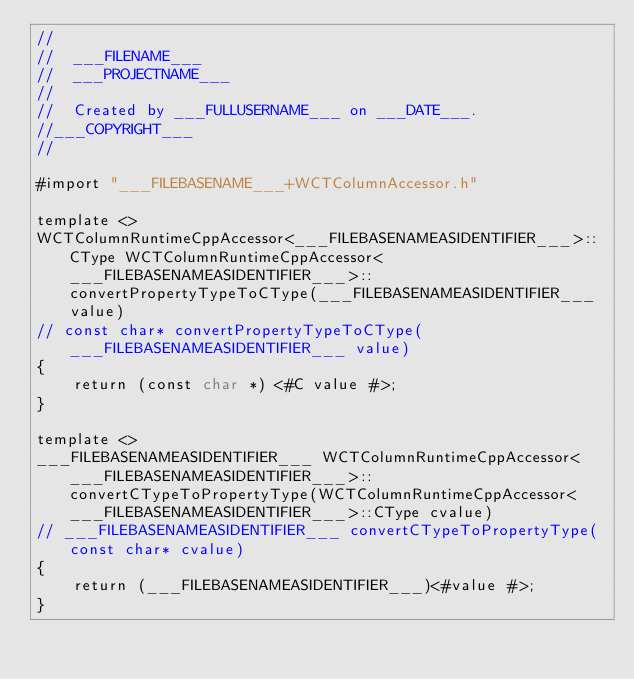<code> <loc_0><loc_0><loc_500><loc_500><_ObjectiveC_>//
//  ___FILENAME___
//  ___PROJECTNAME___
//
//  Created by ___FULLUSERNAME___ on ___DATE___.
//___COPYRIGHT___
//

#import "___FILEBASENAME___+WCTColumnAccessor.h"

template <>
WCTColumnRuntimeCppAccessor<___FILEBASENAMEASIDENTIFIER___>::CType WCTColumnRuntimeCppAccessor<___FILEBASENAMEASIDENTIFIER___>::convertPropertyTypeToCType(___FILEBASENAMEASIDENTIFIER___ value)
// const char* convertPropertyTypeToCType(___FILEBASENAMEASIDENTIFIER___ value)
{
    return (const char *) <#C value #>;
}

template <>
___FILEBASENAMEASIDENTIFIER___ WCTColumnRuntimeCppAccessor<___FILEBASENAMEASIDENTIFIER___>::convertCTypeToPropertyType(WCTColumnRuntimeCppAccessor<___FILEBASENAMEASIDENTIFIER___>::CType cvalue)
// ___FILEBASENAMEASIDENTIFIER___ convertCTypeToPropertyType(const char* cvalue)
{
    return (___FILEBASENAMEASIDENTIFIER___)<#value #>;
}
</code> 